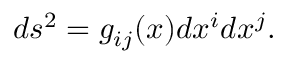<formula> <loc_0><loc_0><loc_500><loc_500>\begin{array} { r } { d s ^ { 2 } = g _ { i j } ( x ) d x ^ { i } d x ^ { j } . } \end{array}</formula> 